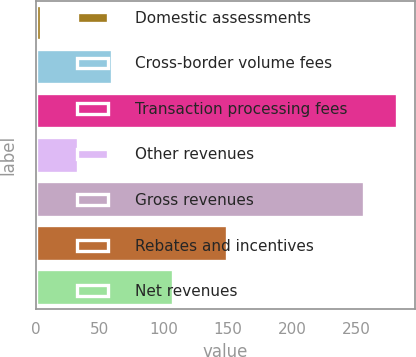Convert chart to OTSL. <chart><loc_0><loc_0><loc_500><loc_500><bar_chart><fcel>Domestic assessments<fcel>Cross-border volume fees<fcel>Transaction processing fees<fcel>Other revenues<fcel>Gross revenues<fcel>Rebates and incentives<fcel>Net revenues<nl><fcel>4<fcel>59.1<fcel>282.1<fcel>33<fcel>256<fcel>149<fcel>107<nl></chart> 